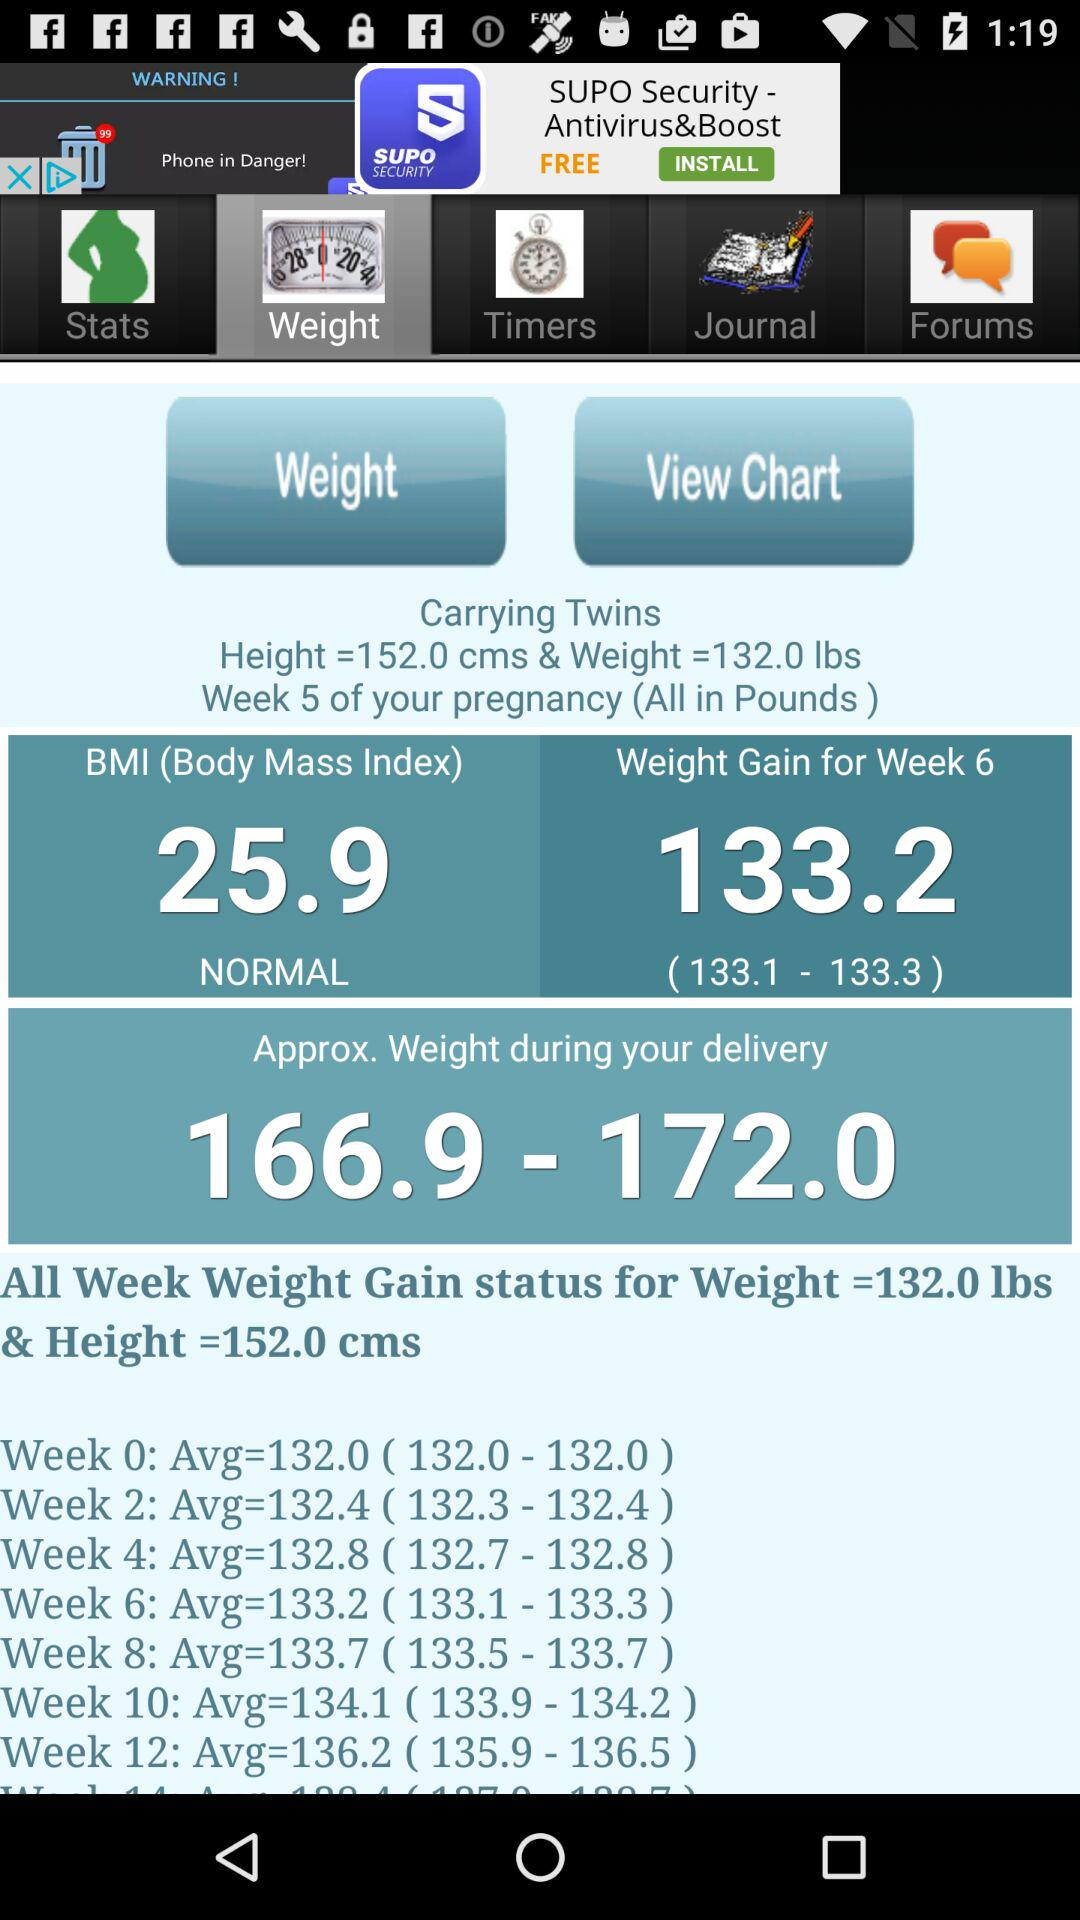What is the weight gain in the sixth week? The weight gain in the sixth week is 133.2 lbs. 